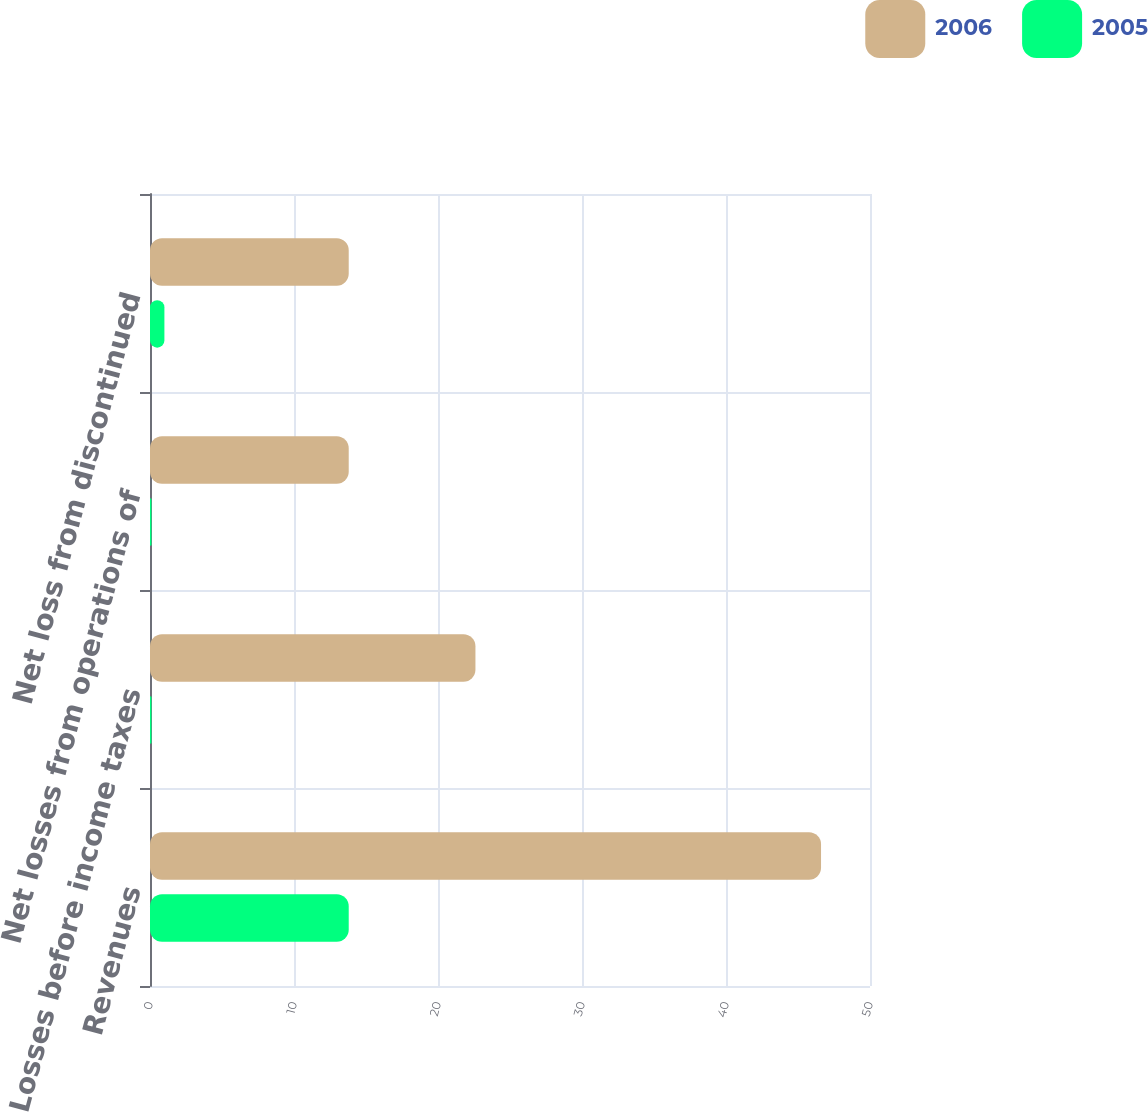<chart> <loc_0><loc_0><loc_500><loc_500><stacked_bar_chart><ecel><fcel>Revenues<fcel>Losses before income taxes<fcel>Net losses from operations of<fcel>Net loss from discontinued<nl><fcel>2006<fcel>46.6<fcel>22.6<fcel>13.8<fcel>13.8<nl><fcel>2005<fcel>13.8<fcel>0.1<fcel>0.1<fcel>1<nl></chart> 